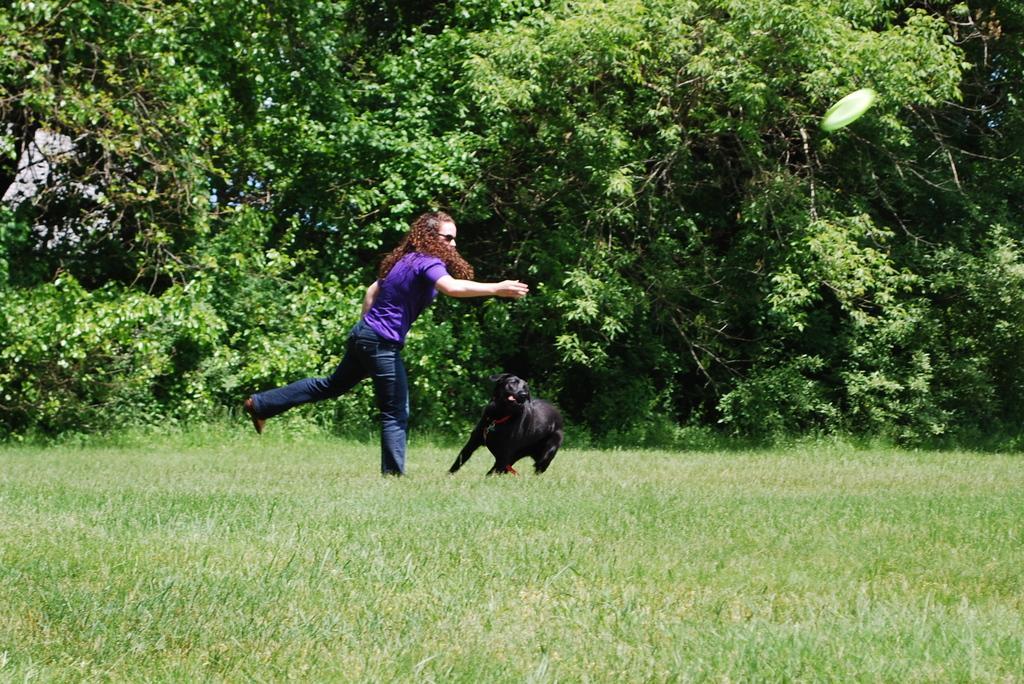Could you give a brief overview of what you see in this image? In this image in the front there's grass on the ground. In the center there is an animal and there is person. In the background there are trees. On the right side in the center there is a frisbee in the air. 